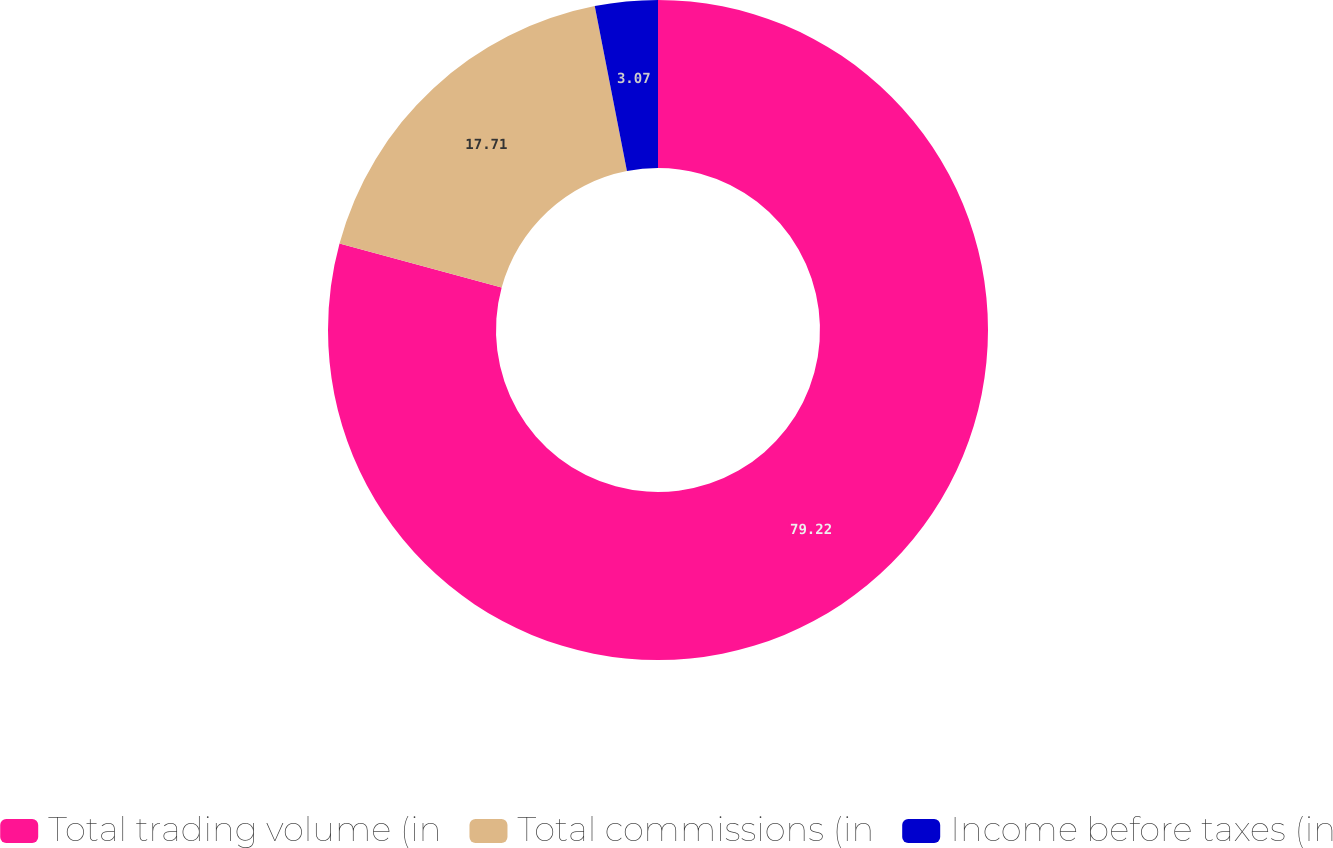<chart> <loc_0><loc_0><loc_500><loc_500><pie_chart><fcel>Total trading volume (in<fcel>Total commissions (in<fcel>Income before taxes (in<nl><fcel>79.22%<fcel>17.71%<fcel>3.07%<nl></chart> 